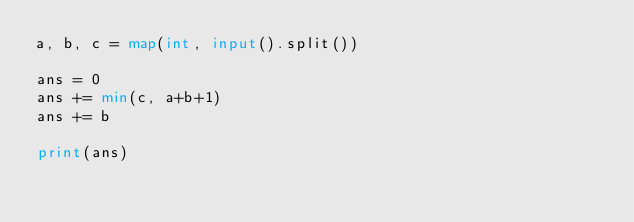<code> <loc_0><loc_0><loc_500><loc_500><_Python_>a, b, c = map(int, input().split())

ans = 0
ans += min(c, a+b+1)
ans += b

print(ans)
</code> 